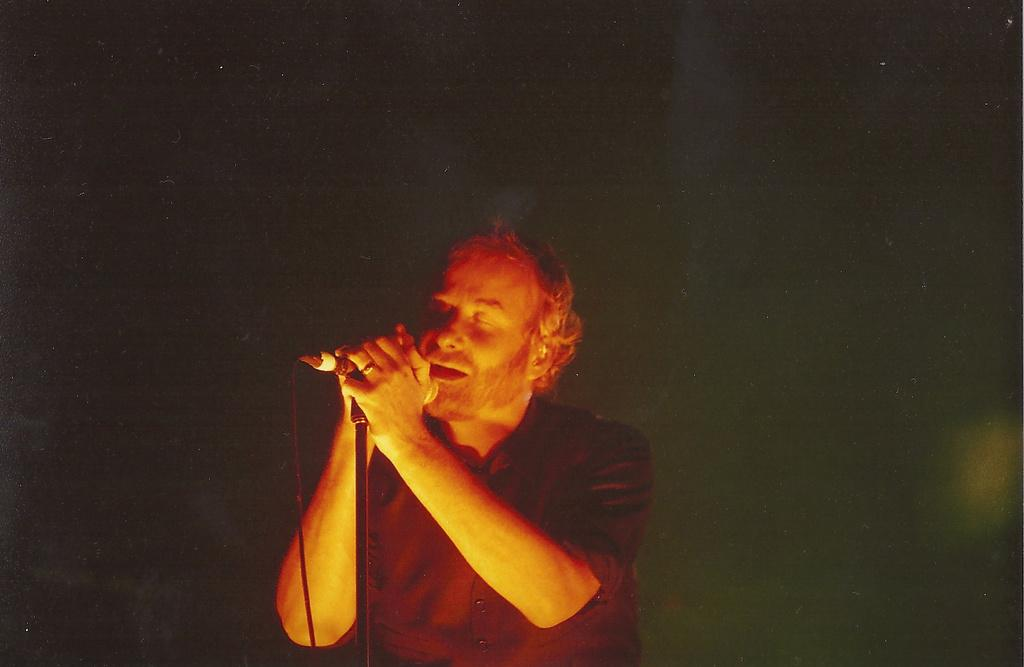What is the main subject of the image? The main subject of the image is a man standing in the center of the image. What is the man holding in the image? The man is holding a mic in the image. How is the mic positioned in the image? The mic is placed on a stand in the image. What type of voyage is the man embarking on in the image? There is no indication of a voyage in the image; it simply shows a man holding a mic on a stand. What is the texture of the mic in the image? The texture of the mic cannot be determined from the image, as it is a two-dimensional representation. 